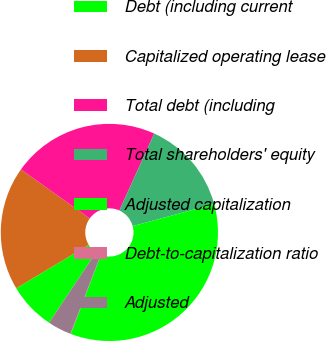Convert chart. <chart><loc_0><loc_0><loc_500><loc_500><pie_chart><fcel>Debt (including current<fcel>Capitalized operating lease<fcel>Total debt (including<fcel>Total shareholders' equity<fcel>Adjusted capitalization<fcel>Debt-to-capitalization ratio<fcel>Adjusted<nl><fcel>7.04%<fcel>18.44%<fcel>21.93%<fcel>14.01%<fcel>35.0%<fcel>0.05%<fcel>3.54%<nl></chart> 